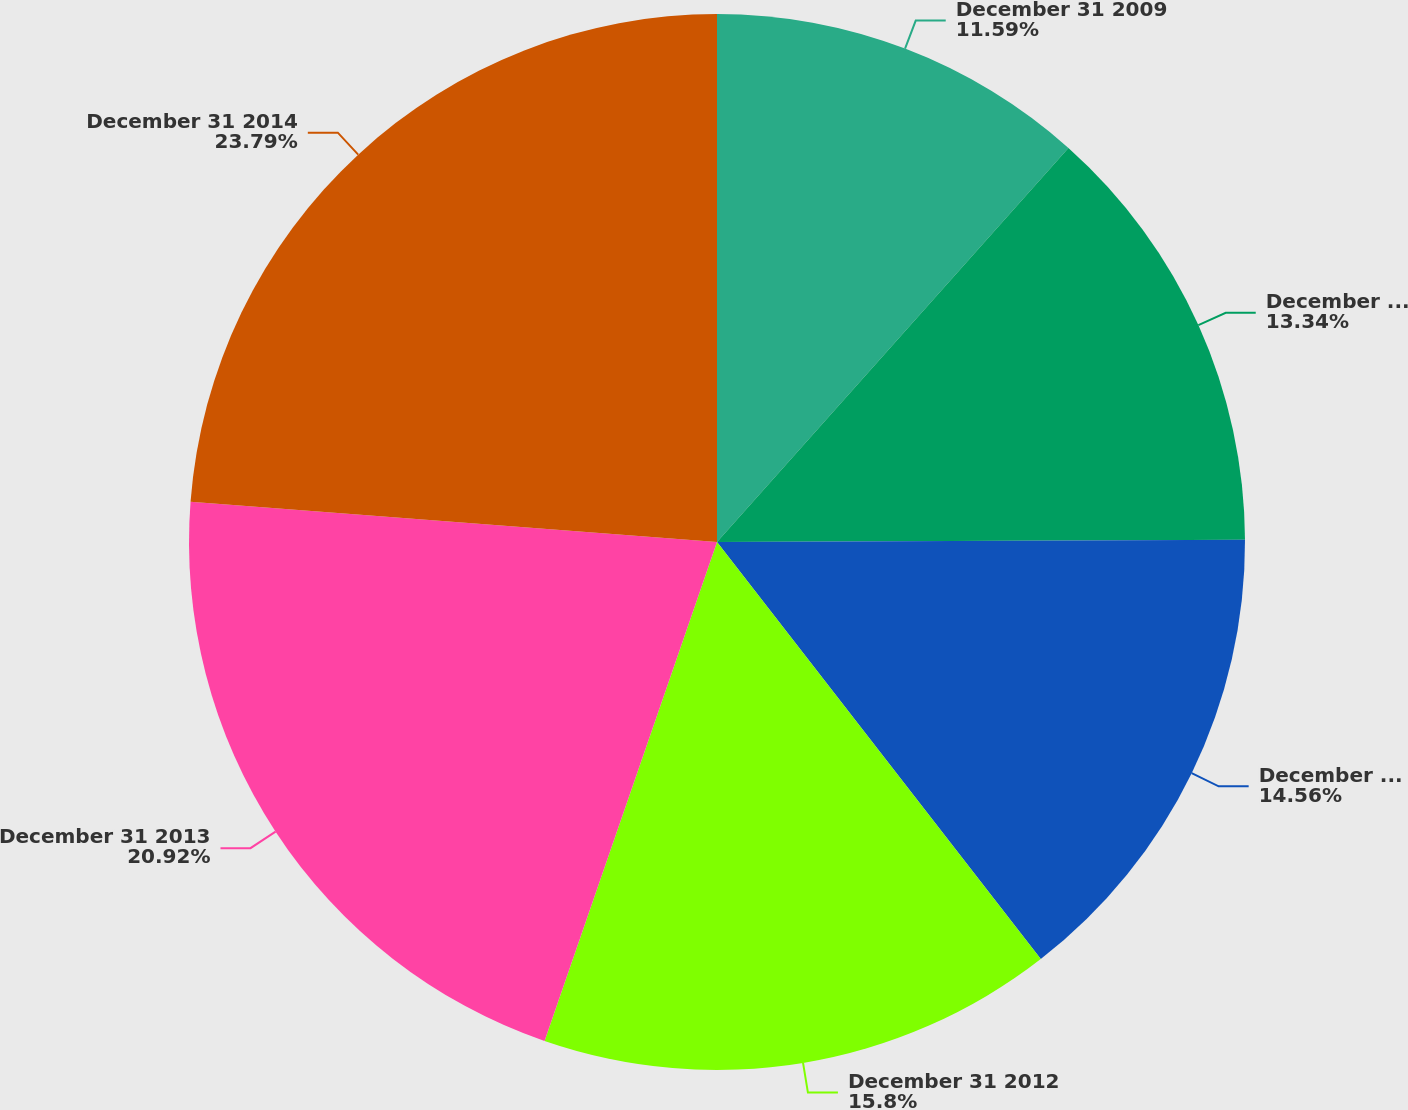Convert chart. <chart><loc_0><loc_0><loc_500><loc_500><pie_chart><fcel>December 31 2009<fcel>December 31 2010<fcel>December 31 2011<fcel>December 31 2012<fcel>December 31 2013<fcel>December 31 2014<nl><fcel>11.59%<fcel>13.34%<fcel>14.56%<fcel>15.8%<fcel>20.92%<fcel>23.78%<nl></chart> 